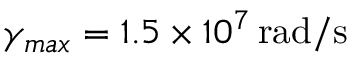<formula> <loc_0><loc_0><loc_500><loc_500>\gamma _ { \max } = 1 . 5 \times 1 0 ^ { 7 } \, r a d / s</formula> 